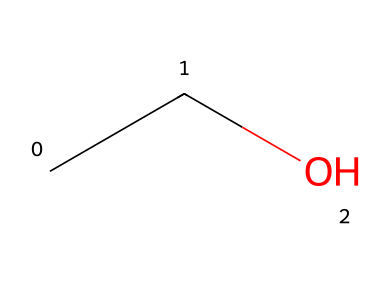How many carbon atoms are in ethanol? The SMILES representation "CCO" shows that there are two 'C' characters in the chain, indicating two carbon atoms.
Answer: two What is the total number of hydrogen atoms in ethanol? In the structure "CCO", each carbon atom is typically bonded to sufficient hydrogen atoms to form four total bonds. The first carbon connects to three hydrogens and the second carbon connects to two, with one hydrogen from the terminal hydroxyl group. Thus, there are five hydrogen atoms in total.
Answer: six What functional group is present in ethanol? The structure "CCO" indicates the presence of a hydroxyl group (-OH) attached to the carbon chain, which defines it as an alcohol.
Answer: hydroxyl group Is ethanol polar or nonpolar? Due to the polar -OH group in the structure "CCO", it shows a notable dipole moment, making ethanol polar.
Answer: polar What type of solvent is ethanol classified as? Based on its structure "CCO" and properties, ethanol is known to dissolve a wide range of substances due to its polarity and is therefore classified as a protic solvent.
Answer: protic solvent Why is ethanol soluble in water? The presence of the polar hydroxyl group (-OH) in the structure "CCO" allows ethanol to form hydrogen bonds with water molecules, enhancing its solubility in water.
Answer: hydrogen bonding 